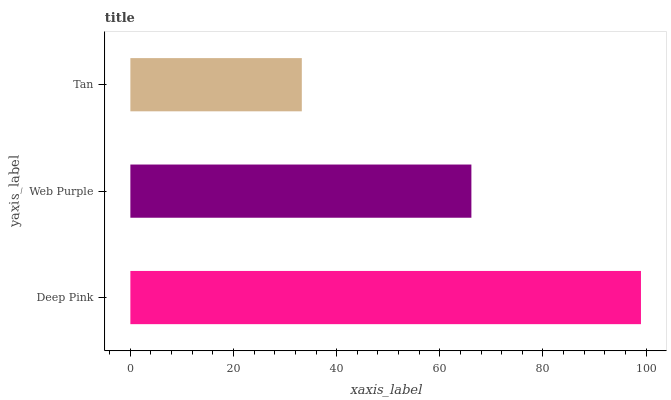Is Tan the minimum?
Answer yes or no. Yes. Is Deep Pink the maximum?
Answer yes or no. Yes. Is Web Purple the minimum?
Answer yes or no. No. Is Web Purple the maximum?
Answer yes or no. No. Is Deep Pink greater than Web Purple?
Answer yes or no. Yes. Is Web Purple less than Deep Pink?
Answer yes or no. Yes. Is Web Purple greater than Deep Pink?
Answer yes or no. No. Is Deep Pink less than Web Purple?
Answer yes or no. No. Is Web Purple the high median?
Answer yes or no. Yes. Is Web Purple the low median?
Answer yes or no. Yes. Is Tan the high median?
Answer yes or no. No. Is Deep Pink the low median?
Answer yes or no. No. 